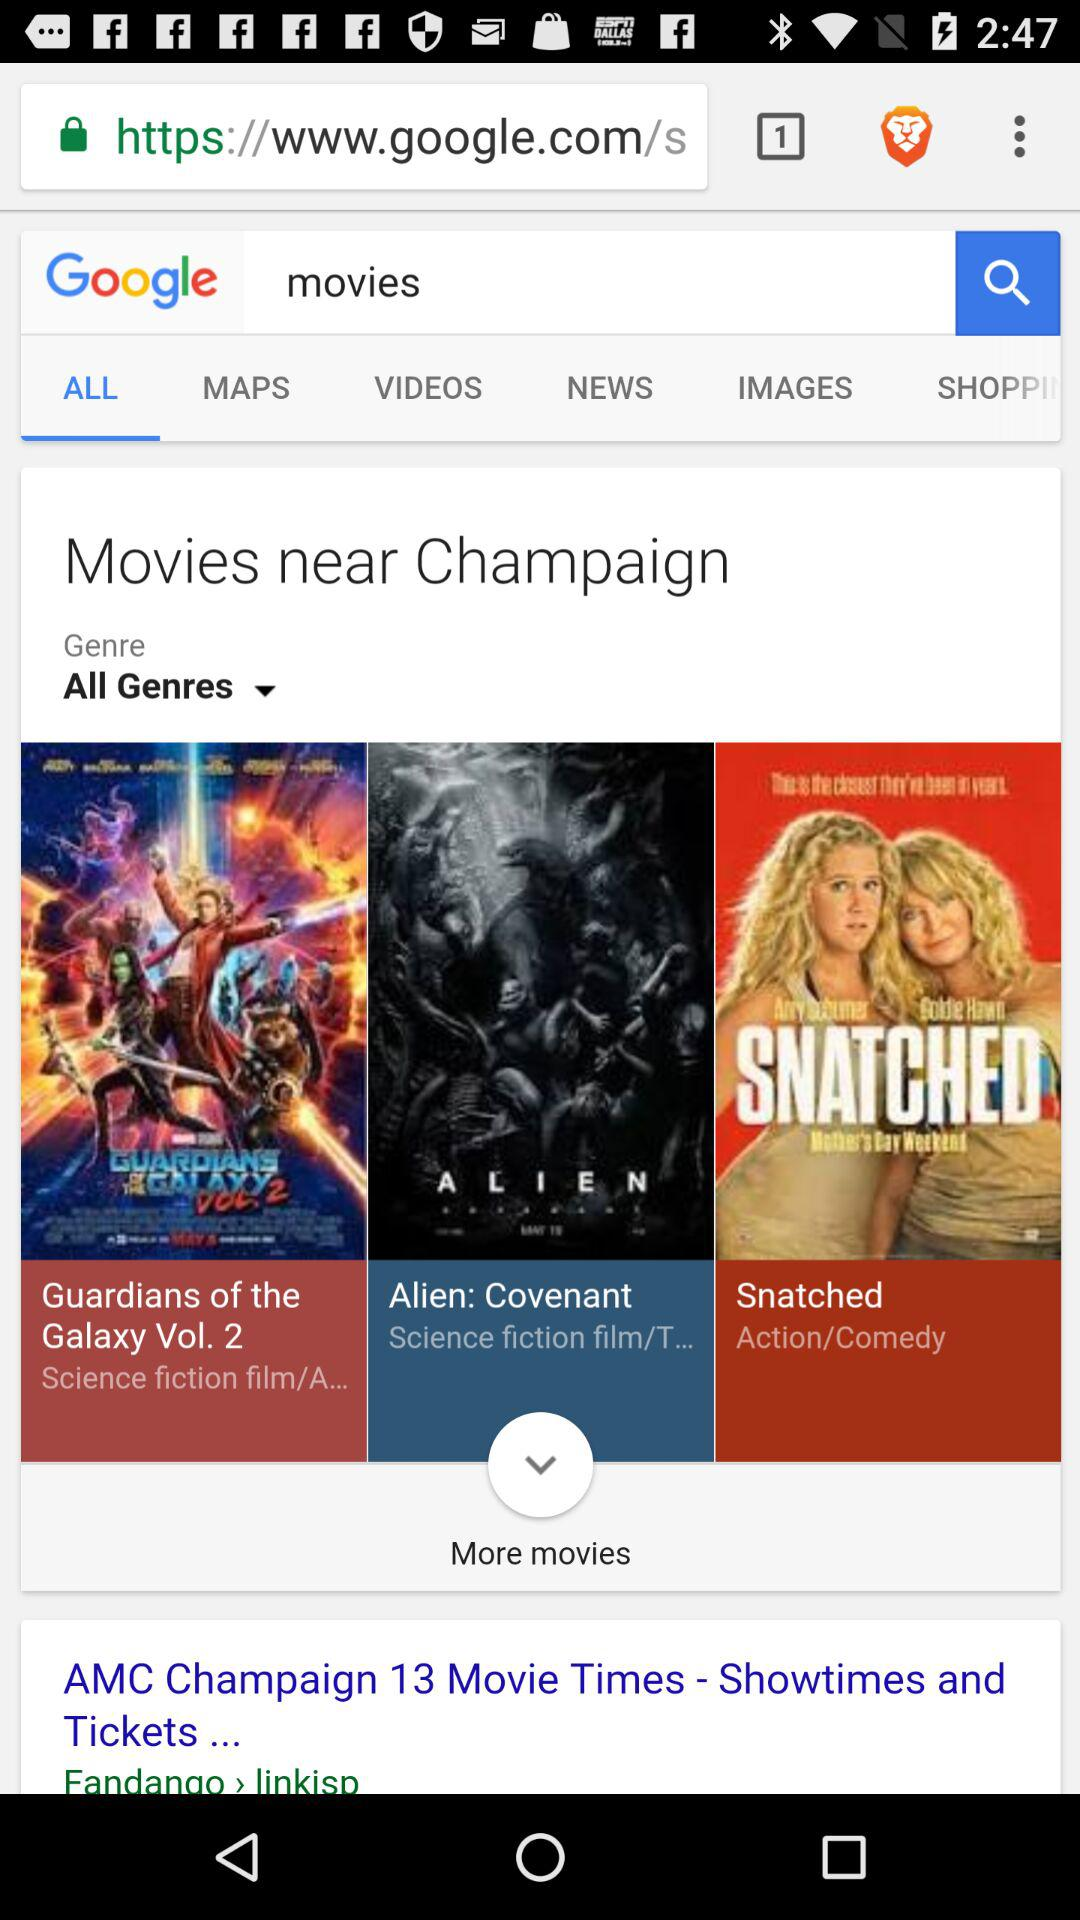What is the selected tab? The selected tab is "ALL". 